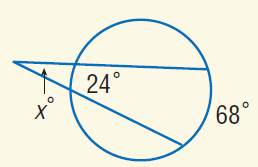Answer the mathemtical geometry problem and directly provide the correct option letter.
Question: Find x.
Choices: A: 22 B: 24 C: 43 D: 68 A 